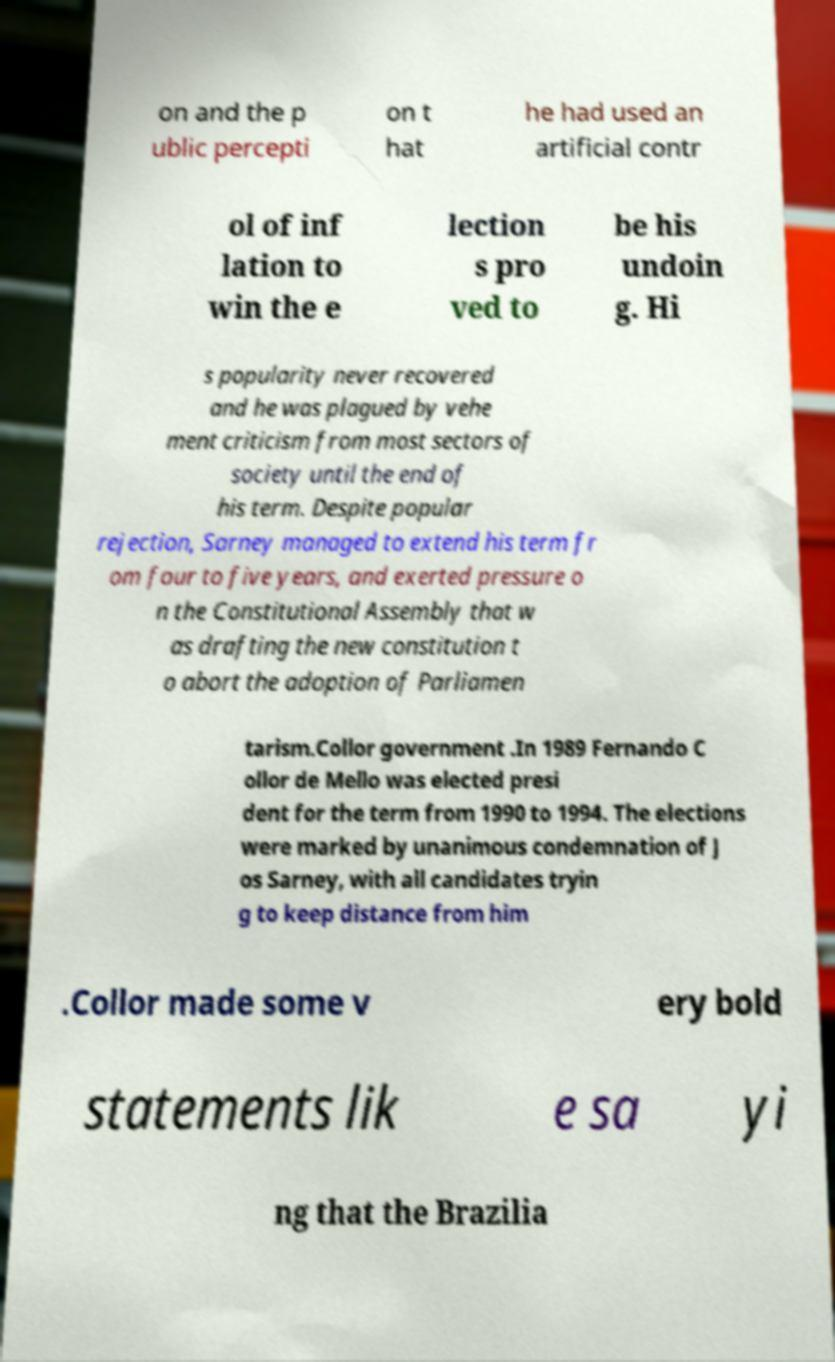What historical context is indicated by the names mentioned in the document? The text references Brazilian leaders Jos� Sarney and Fernando Collor de Mello. Sarney, who faced criticism for extending his presidential term and his administration's handling of economic issues, while Collor's presidency, starting in 1990, is noted for its controversial reform efforts and eventual impeachment. 